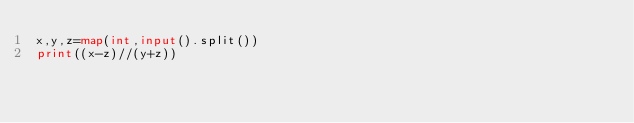<code> <loc_0><loc_0><loc_500><loc_500><_Python_>x,y,z=map(int,input().split())
print((x-z)//(y+z))</code> 